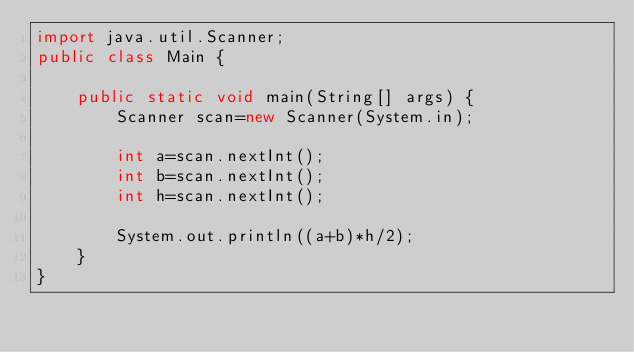<code> <loc_0><loc_0><loc_500><loc_500><_Java_>import java.util.Scanner;
public class Main {

    public static void main(String[] args) {
        Scanner scan=new Scanner(System.in);

        int a=scan.nextInt();
        int b=scan.nextInt();
        int h=scan.nextInt();

        System.out.println((a+b)*h/2);
    }
}
</code> 